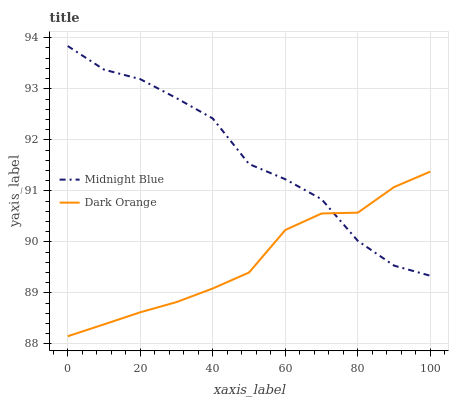Does Midnight Blue have the minimum area under the curve?
Answer yes or no. No. Is Midnight Blue the smoothest?
Answer yes or no. No. Does Midnight Blue have the lowest value?
Answer yes or no. No. 